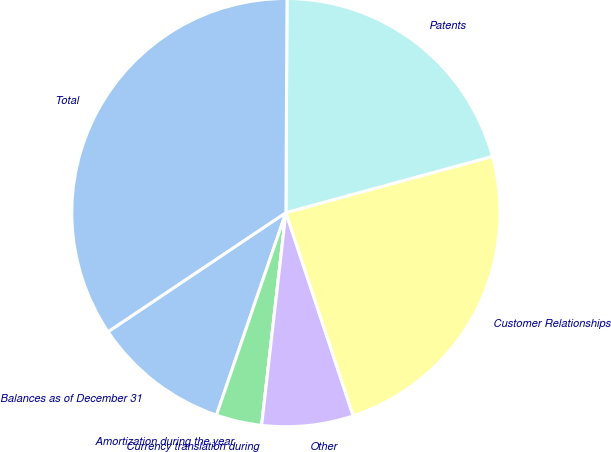<chart> <loc_0><loc_0><loc_500><loc_500><pie_chart><fcel>Balances as of December 31<fcel>Amortization during the year<fcel>Currency translation during<fcel>Other<fcel>Customer Relationships<fcel>Patents<fcel>Total<nl><fcel>10.35%<fcel>3.45%<fcel>0.0%<fcel>6.9%<fcel>24.14%<fcel>20.69%<fcel>34.48%<nl></chart> 